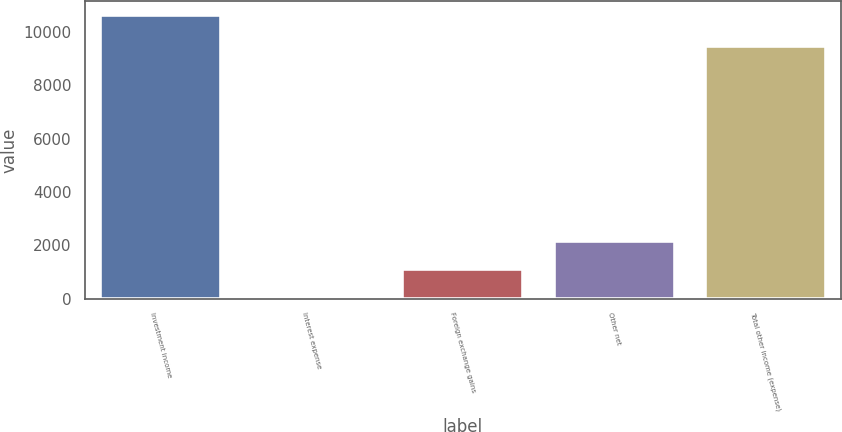<chart> <loc_0><loc_0><loc_500><loc_500><bar_chart><fcel>Investment income<fcel>Interest expense<fcel>Foreign exchange gains<fcel>Other net<fcel>Total other income (expense)<nl><fcel>10628<fcel>44<fcel>1102.4<fcel>2160.8<fcel>9475<nl></chart> 